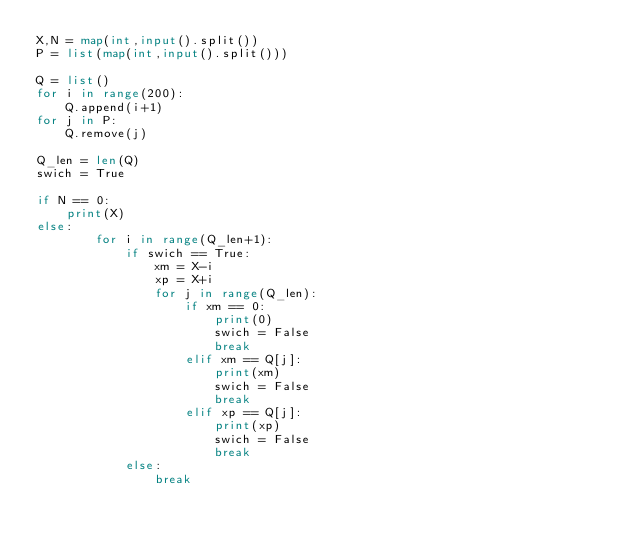<code> <loc_0><loc_0><loc_500><loc_500><_Python_>X,N = map(int,input().split())
P = list(map(int,input().split()))

Q = list()
for i in range(200):
    Q.append(i+1)
for j in P:
    Q.remove(j)

Q_len = len(Q)
swich = True

if N == 0:
    print(X)
else:
        for i in range(Q_len+1):
            if swich == True:
                xm = X-i
                xp = X+i
                for j in range(Q_len):
                    if xm == 0:
                        print(0)
                        swich = False
                        break
                    elif xm == Q[j]:
                        print(xm)
                        swich = False
                        break
                    elif xp == Q[j]:
                        print(xp)
                        swich = False
                        break
            else:
                break
            </code> 